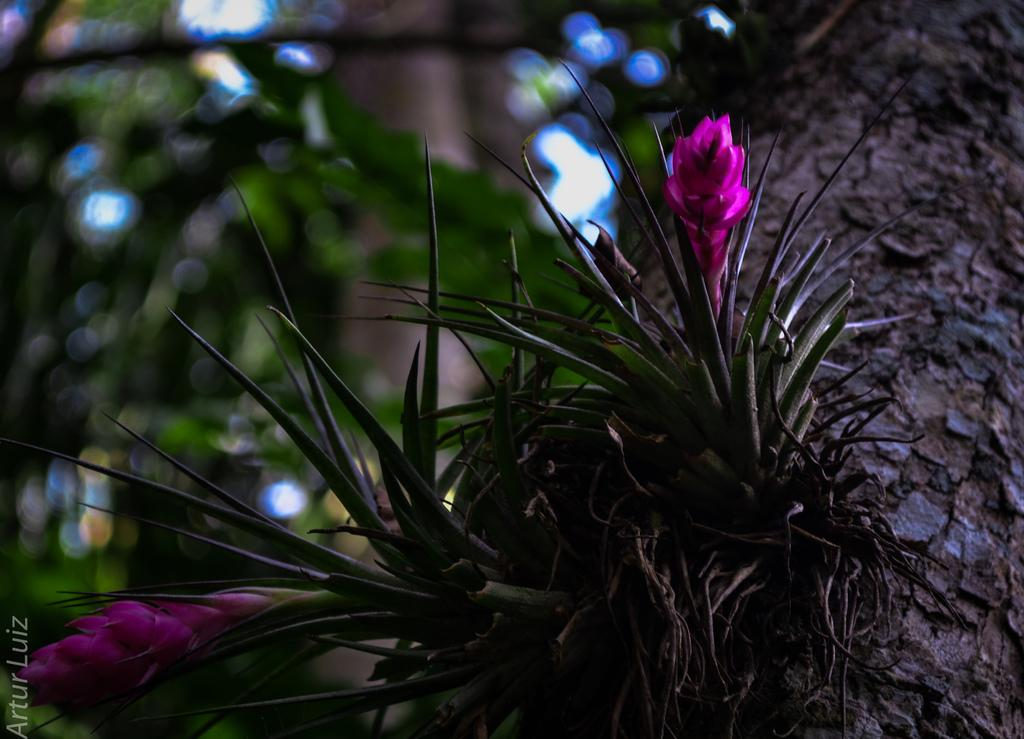What type of vegetation can be seen in the image? There are plants and flowers in the image. What part of a tree is visible in the image? There is a tree trunk in the image. What can be seen in the background of the image? There are trees visible in the background of the image. How would you describe the background of the image? The background of the image is blurry. What type of rat can be seen crawling on the tree trunk in the image? There is no rat present in the image. 